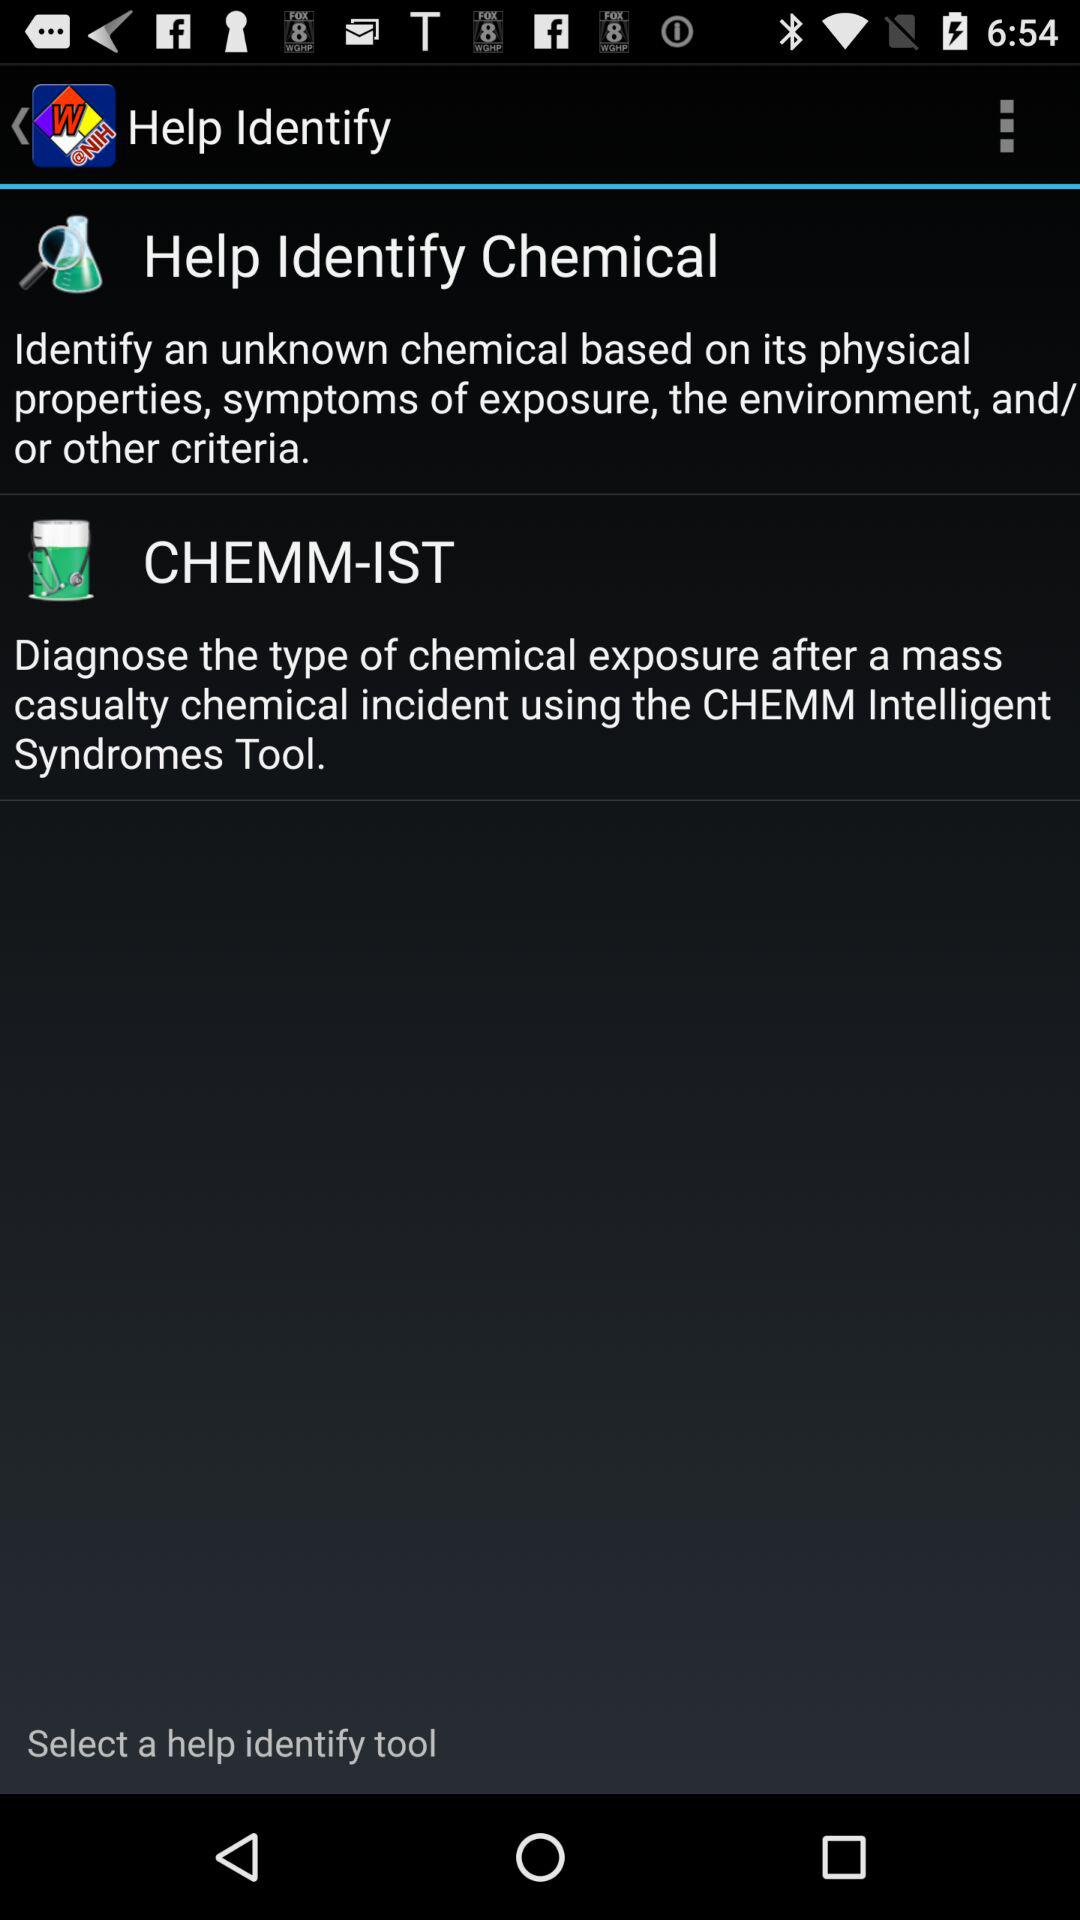How many help identify tools are available?
Answer the question using a single word or phrase. 2 